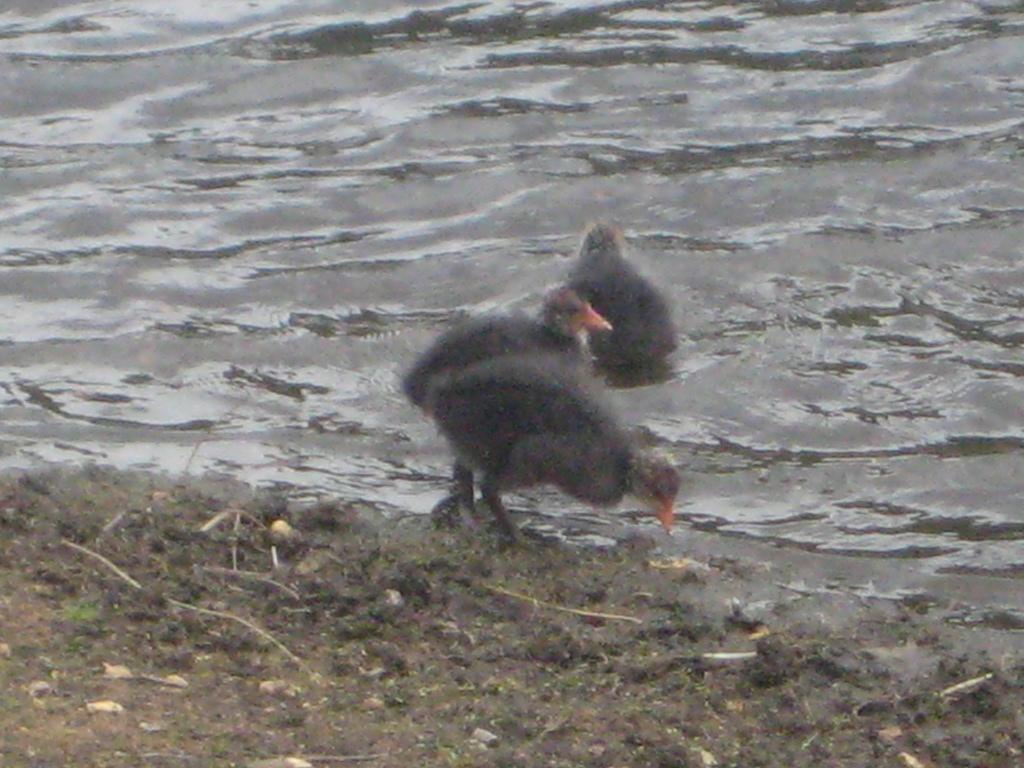Can you describe this image briefly? In the center of the image some birds are there. At the bottom of the image ground is present. At the top of the image water is there. 